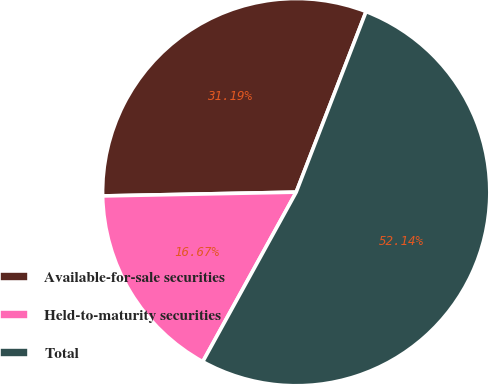Convert chart to OTSL. <chart><loc_0><loc_0><loc_500><loc_500><pie_chart><fcel>Available-for-sale securities<fcel>Held-to-maturity securities<fcel>Total<nl><fcel>31.19%<fcel>16.67%<fcel>52.14%<nl></chart> 